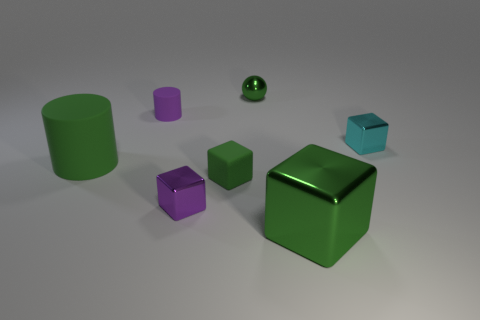What material is the green sphere that is the same size as the cyan object?
Your answer should be very brief. Metal. There is a cyan cube; what number of green metal spheres are in front of it?
Provide a succinct answer. 0. There is a large thing that is to the right of the green matte cylinder; is it the same shape as the small green matte object?
Provide a succinct answer. Yes. Are there any red rubber objects of the same shape as the large green rubber object?
Keep it short and to the point. No. There is a large block that is the same color as the ball; what is it made of?
Your response must be concise. Metal. What shape is the shiny thing that is right of the large green thing right of the small purple metal cube?
Make the answer very short. Cube. How many large red balls are made of the same material as the tiny cylinder?
Your response must be concise. 0. What color is the large object that is the same material as the cyan cube?
Make the answer very short. Green. There is a shiny block that is behind the purple object that is in front of the large thing on the left side of the small green rubber block; what is its size?
Make the answer very short. Small. Are there fewer green balls than things?
Ensure brevity in your answer.  Yes. 